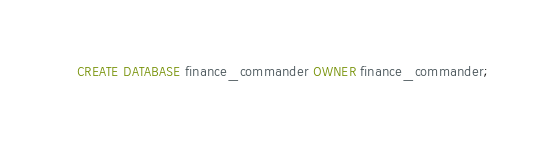Convert code to text. <code><loc_0><loc_0><loc_500><loc_500><_SQL_>CREATE DATABASE finance_commander OWNER finance_commander;</code> 